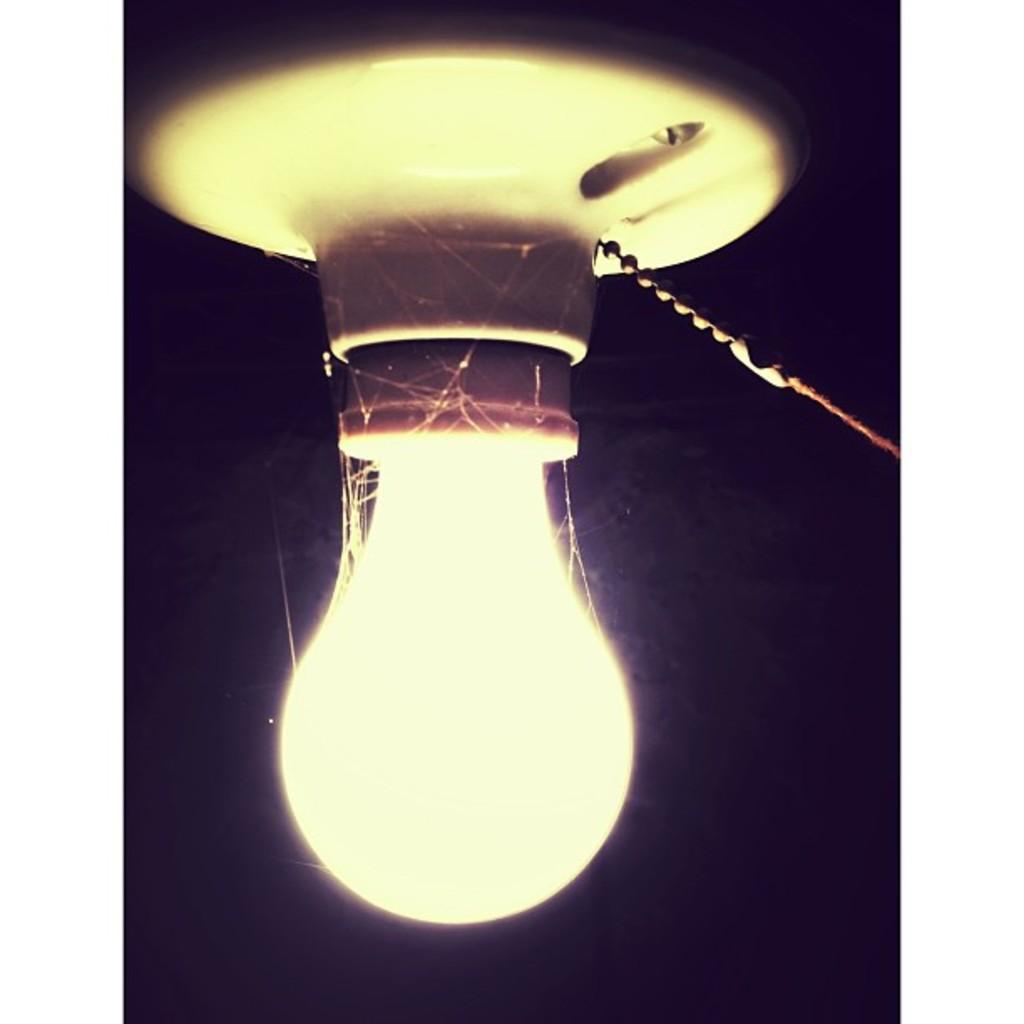What object is present in the image that emits light? There is a bulb in the image, and it is lighted. What is the color or tone of the background in the image? The background of the image is dark. What type of soap is being used to clean the cable in the image? There is no soap or cable present in the image. What items are on a list that is not shown in the image? There is no list present in the image, so it is not possible to determine what items might be on it. 